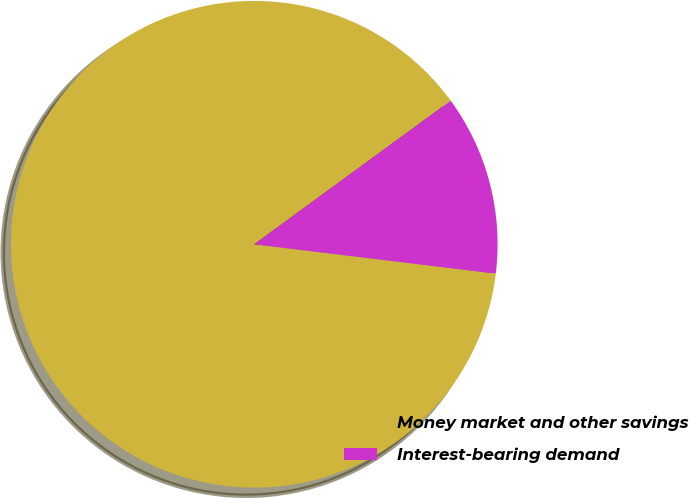Convert chart. <chart><loc_0><loc_0><loc_500><loc_500><pie_chart><fcel>Money market and other savings<fcel>Interest-bearing demand<nl><fcel>88.03%<fcel>11.97%<nl></chart> 